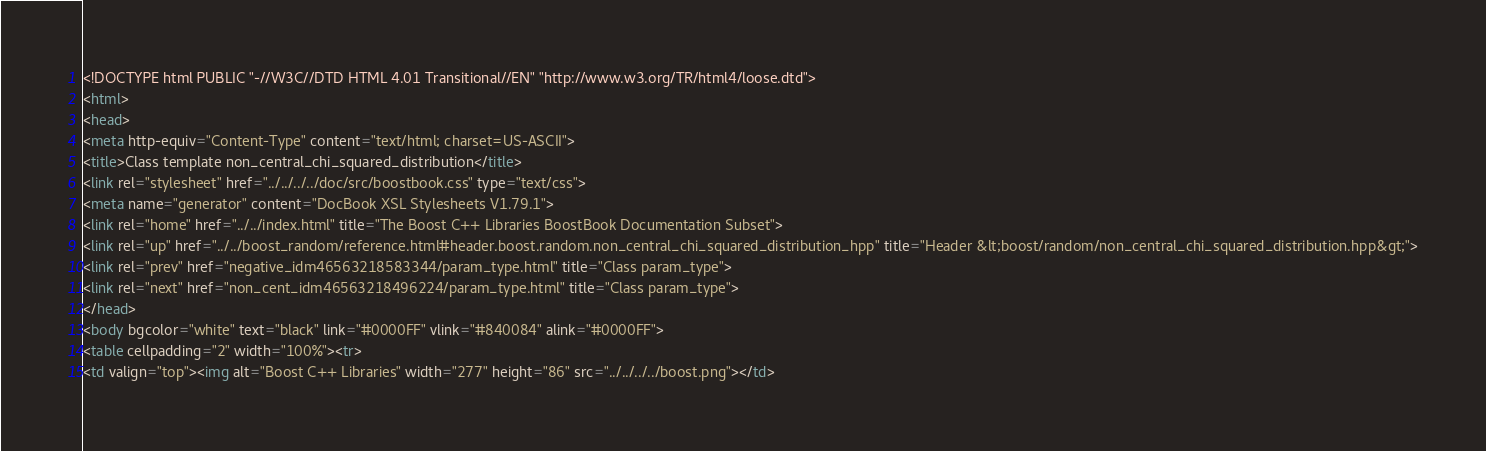Convert code to text. <code><loc_0><loc_0><loc_500><loc_500><_HTML_><!DOCTYPE html PUBLIC "-//W3C//DTD HTML 4.01 Transitional//EN" "http://www.w3.org/TR/html4/loose.dtd">
<html>
<head>
<meta http-equiv="Content-Type" content="text/html; charset=US-ASCII">
<title>Class template non_central_chi_squared_distribution</title>
<link rel="stylesheet" href="../../../../doc/src/boostbook.css" type="text/css">
<meta name="generator" content="DocBook XSL Stylesheets V1.79.1">
<link rel="home" href="../../index.html" title="The Boost C++ Libraries BoostBook Documentation Subset">
<link rel="up" href="../../boost_random/reference.html#header.boost.random.non_central_chi_squared_distribution_hpp" title="Header &lt;boost/random/non_central_chi_squared_distribution.hpp&gt;">
<link rel="prev" href="negative_idm46563218583344/param_type.html" title="Class param_type">
<link rel="next" href="non_cent_idm46563218496224/param_type.html" title="Class param_type">
</head>
<body bgcolor="white" text="black" link="#0000FF" vlink="#840084" alink="#0000FF">
<table cellpadding="2" width="100%"><tr>
<td valign="top"><img alt="Boost C++ Libraries" width="277" height="86" src="../../../../boost.png"></td></code> 